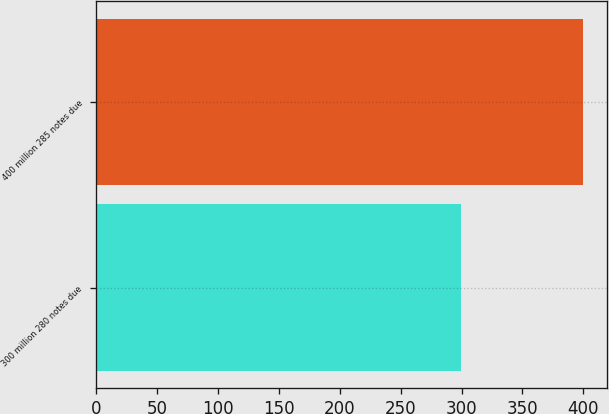<chart> <loc_0><loc_0><loc_500><loc_500><bar_chart><fcel>300 million 280 notes due<fcel>400 million 285 notes due<nl><fcel>299.8<fcel>399.6<nl></chart> 